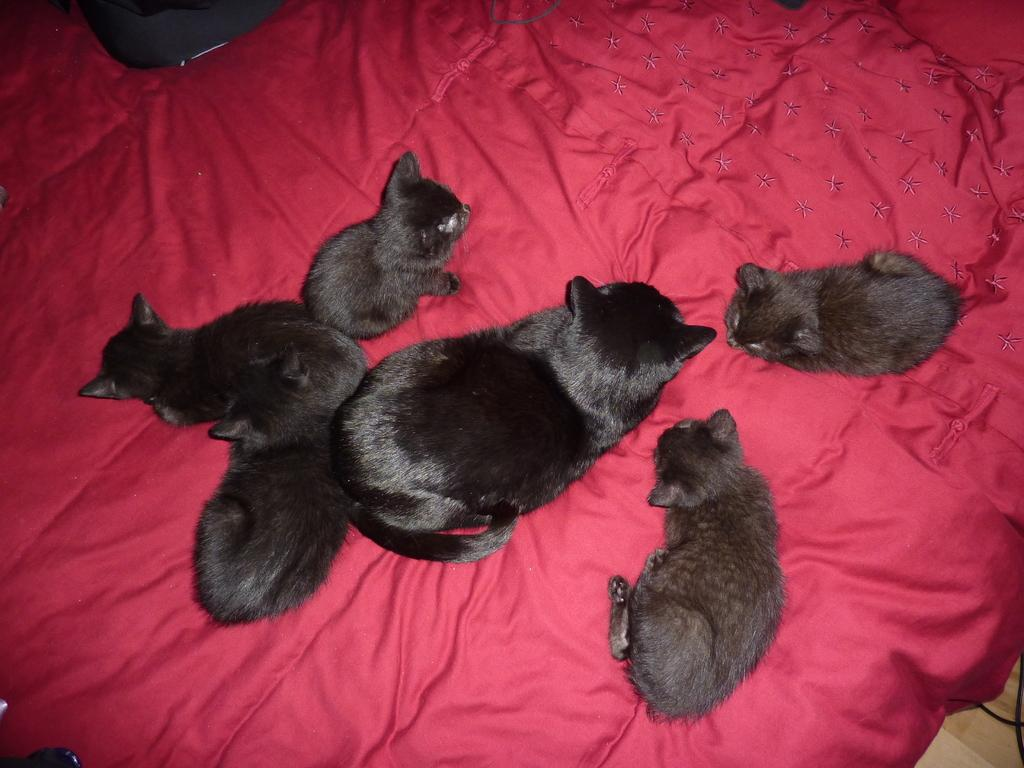What type of animals are in the image? There are cats in the image. Where are the cats located? The cats are on a cloth. What type of wrench is being used by the cats in the image? There is no wrench present in the image; the cats are on a cloth. 